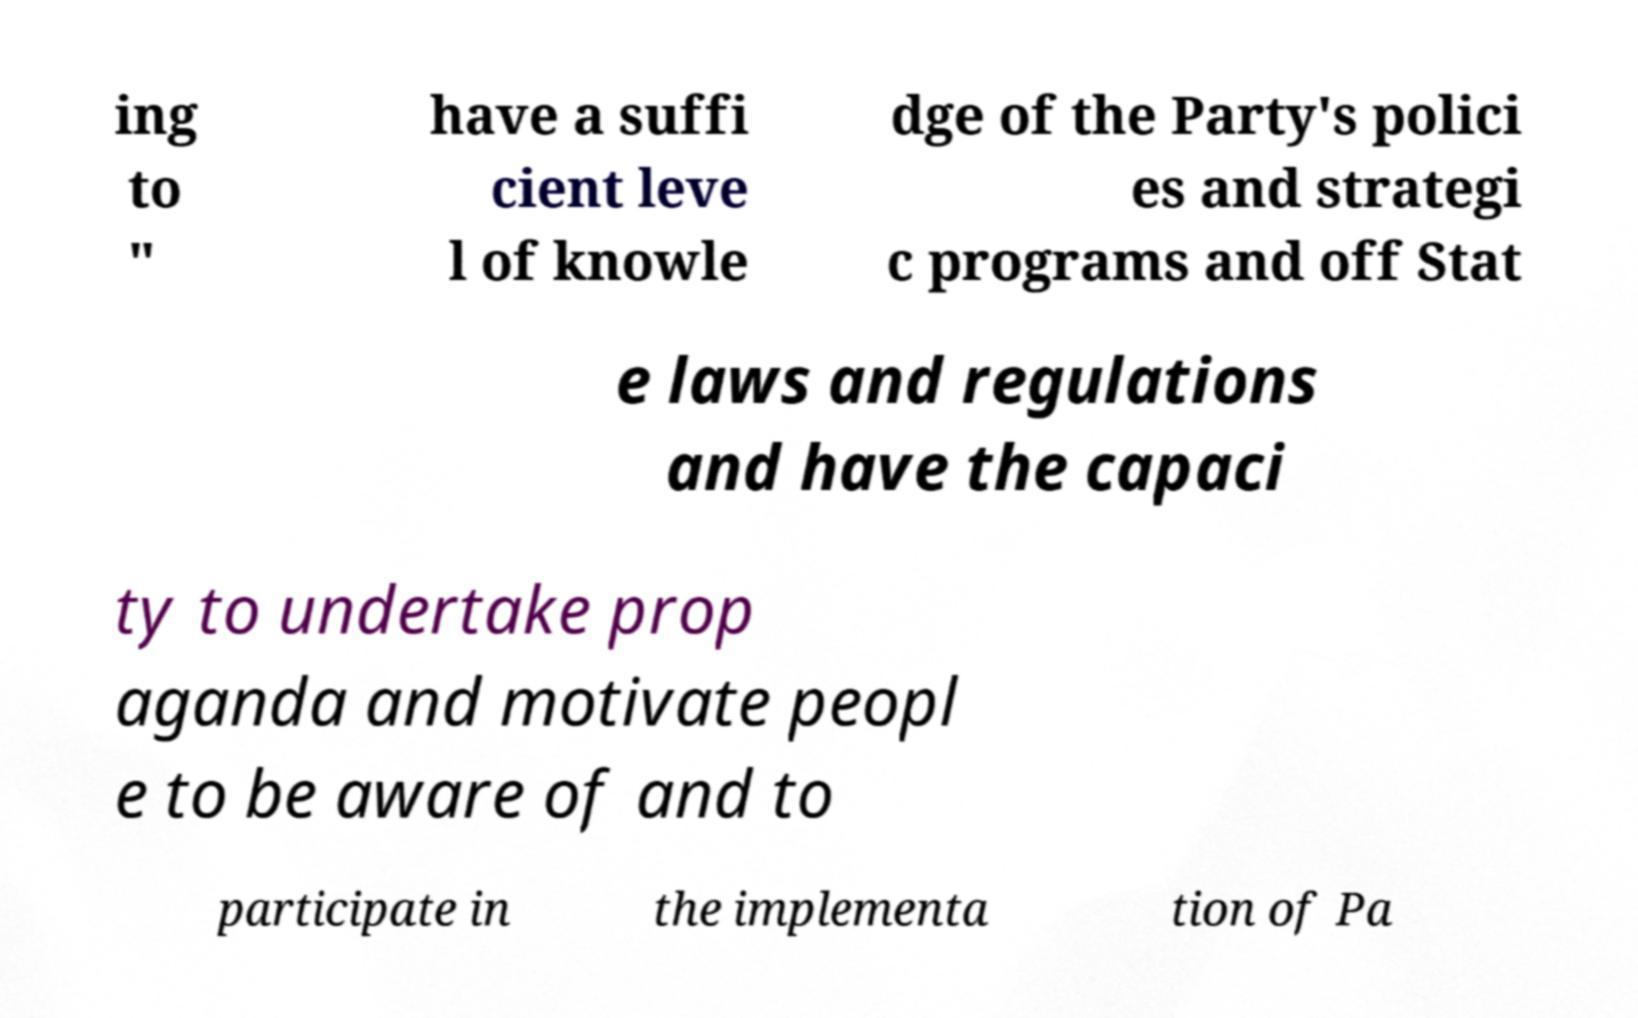Could you assist in decoding the text presented in this image and type it out clearly? ing to " have a suffi cient leve l of knowle dge of the Party's polici es and strategi c programs and off Stat e laws and regulations and have the capaci ty to undertake prop aganda and motivate peopl e to be aware of and to participate in the implementa tion of Pa 